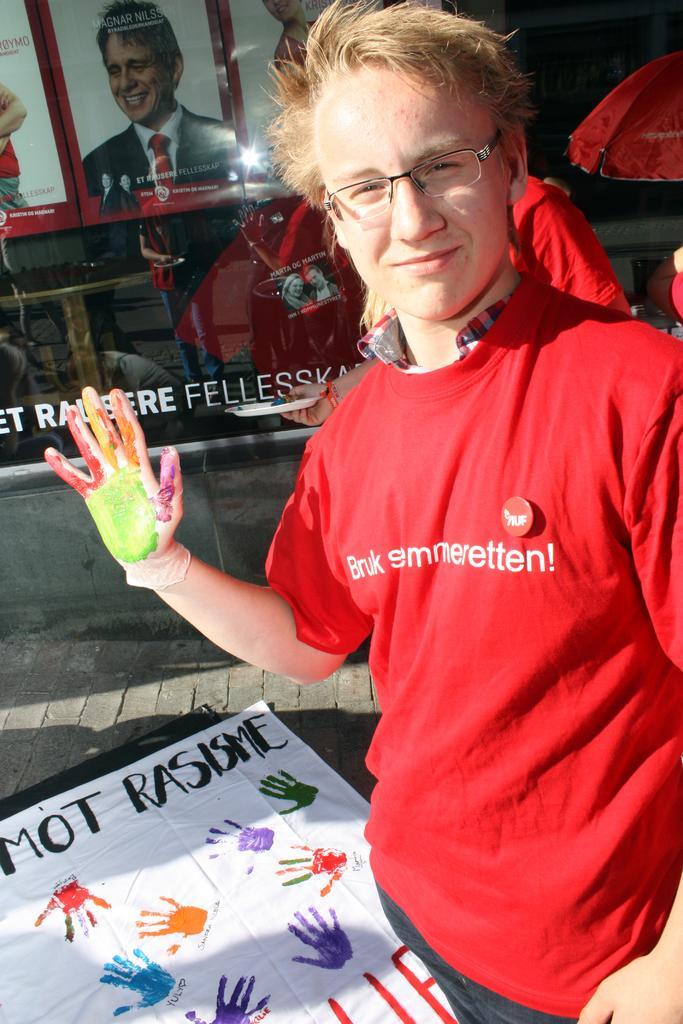In one or two sentences, can you explain what this image depicts? Here I can see a man wearing a red color t-shirt, standing, smiling and giving pose for the picture. There are few colors to his hand. At the bottom there is a white cloth on which I can see some text and few handprints. In the background another person is standing and also there is a glass on which few posters are attached and also I can see some text. 